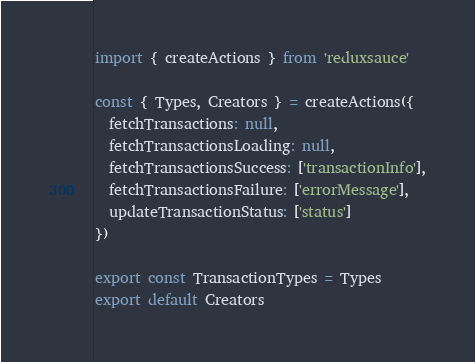Convert code to text. <code><loc_0><loc_0><loc_500><loc_500><_JavaScript_>import { createActions } from 'reduxsauce'

const { Types, Creators } = createActions({
  fetchTransactions: null,
  fetchTransactionsLoading: null,
  fetchTransactionsSuccess: ['transactionInfo'],
  fetchTransactionsFailure: ['errorMessage'],
  updateTransactionStatus: ['status']
})

export const TransactionTypes = Types
export default Creators
</code> 